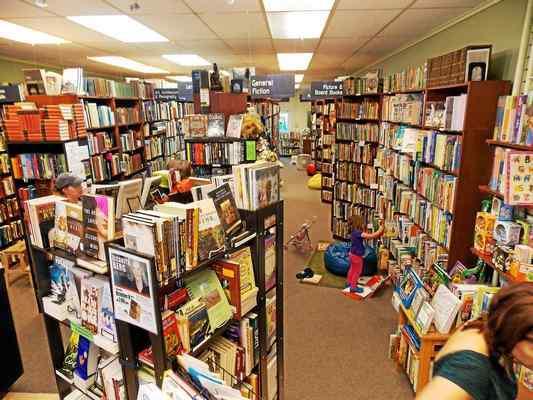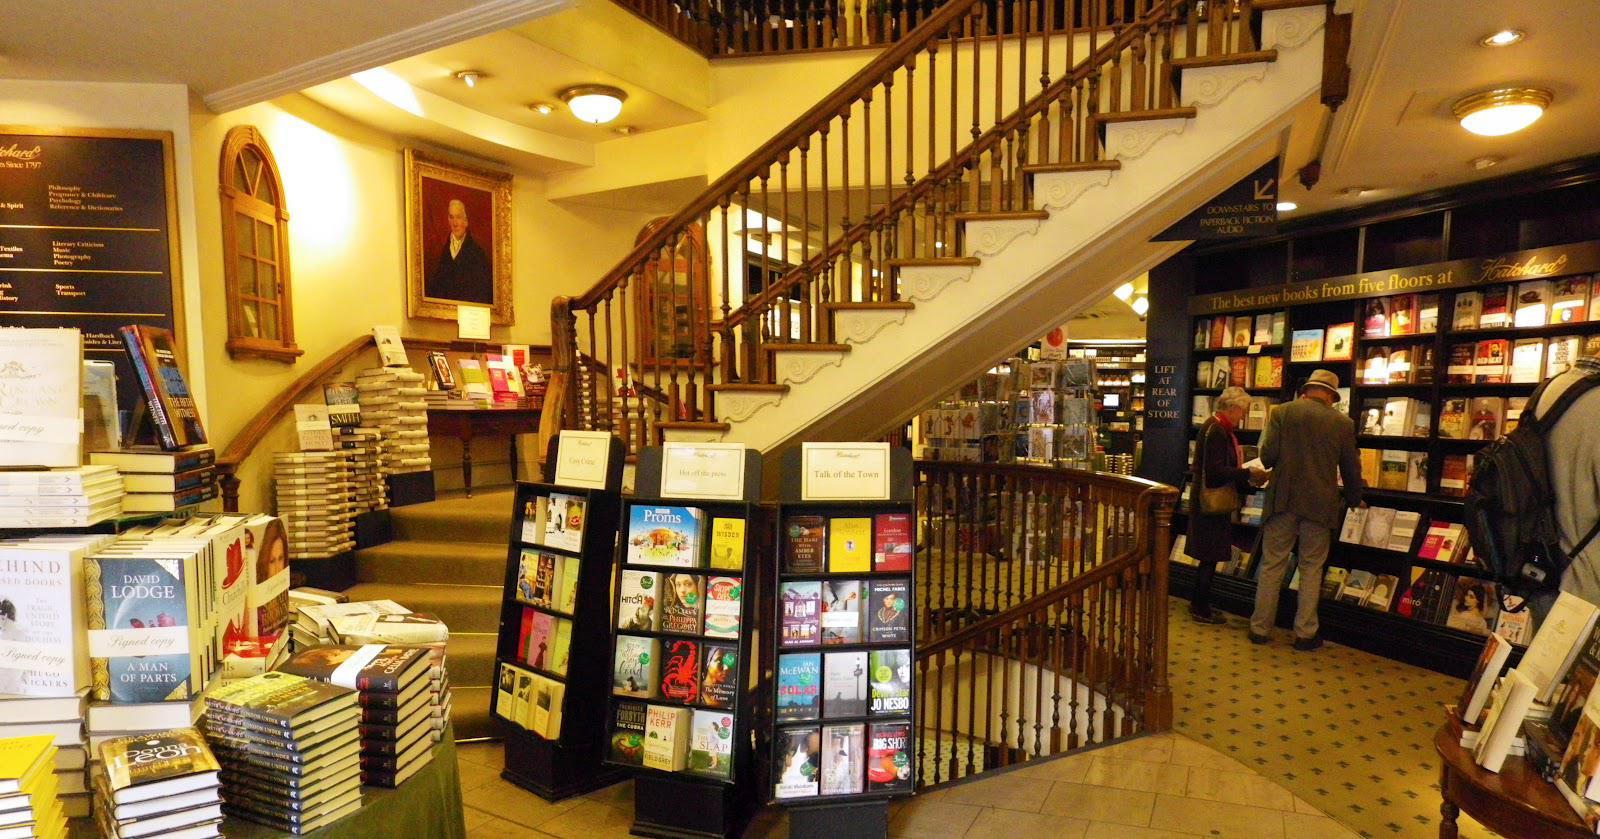The first image is the image on the left, the second image is the image on the right. Examine the images to the left and right. Is the description "In at least one of the images, the source of light is from a track of spotlights on the ceiling." accurate? Answer yes or no. No. 